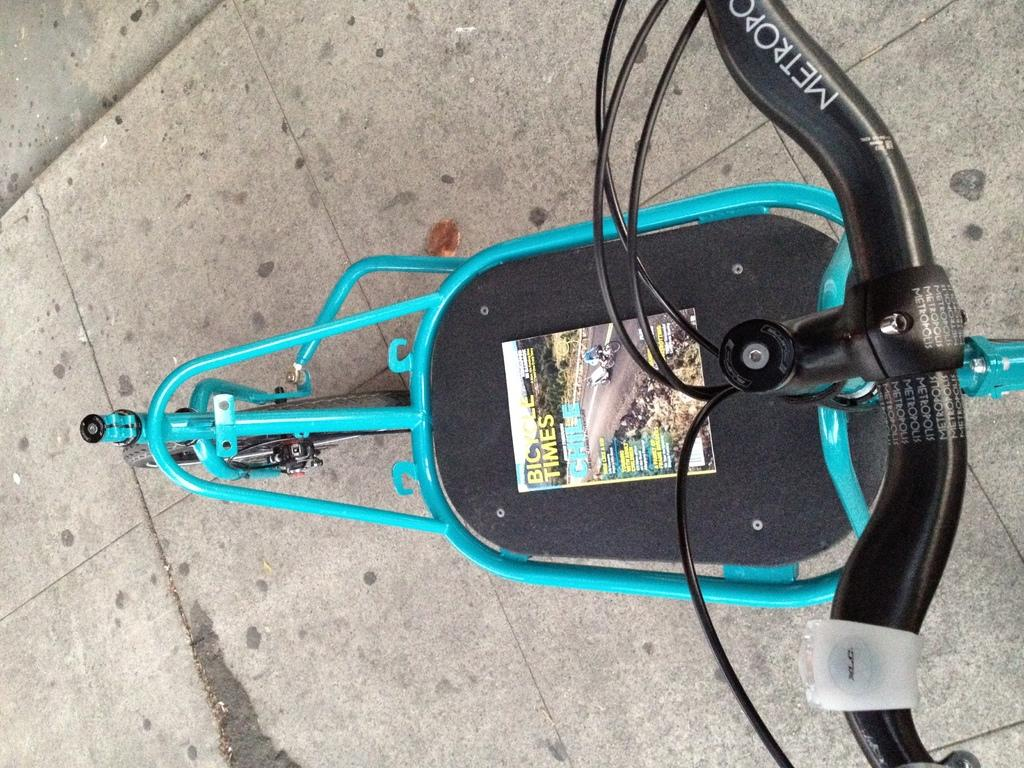What is the main object in the picture? There is a bicycle in the picture. What else can be seen in the picture besides the bicycle? There is a poster with text in the picture. How many family members are depicted on the bicycle in the image? There are no family members depicted on the bicycle in the image; it is just the bicycle itself. What type of star can be seen shining in the background of the image? There is no star visible in the image; it only features a bicycle and a poster with text. 